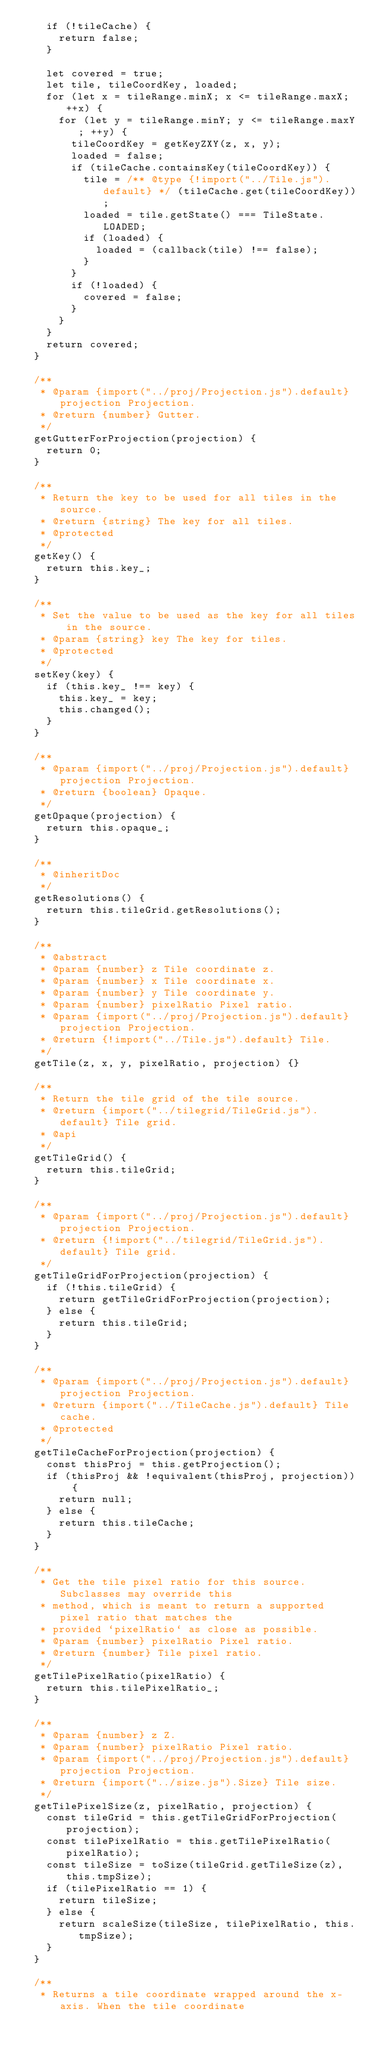Convert code to text. <code><loc_0><loc_0><loc_500><loc_500><_JavaScript_>    if (!tileCache) {
      return false;
    }

    let covered = true;
    let tile, tileCoordKey, loaded;
    for (let x = tileRange.minX; x <= tileRange.maxX; ++x) {
      for (let y = tileRange.minY; y <= tileRange.maxY; ++y) {
        tileCoordKey = getKeyZXY(z, x, y);
        loaded = false;
        if (tileCache.containsKey(tileCoordKey)) {
          tile = /** @type {!import("../Tile.js").default} */ (tileCache.get(tileCoordKey));
          loaded = tile.getState() === TileState.LOADED;
          if (loaded) {
            loaded = (callback(tile) !== false);
          }
        }
        if (!loaded) {
          covered = false;
        }
      }
    }
    return covered;
  }

  /**
   * @param {import("../proj/Projection.js").default} projection Projection.
   * @return {number} Gutter.
   */
  getGutterForProjection(projection) {
    return 0;
  }

  /**
   * Return the key to be used for all tiles in the source.
   * @return {string} The key for all tiles.
   * @protected
   */
  getKey() {
    return this.key_;
  }

  /**
   * Set the value to be used as the key for all tiles in the source.
   * @param {string} key The key for tiles.
   * @protected
   */
  setKey(key) {
    if (this.key_ !== key) {
      this.key_ = key;
      this.changed();
    }
  }

  /**
   * @param {import("../proj/Projection.js").default} projection Projection.
   * @return {boolean} Opaque.
   */
  getOpaque(projection) {
    return this.opaque_;
  }

  /**
   * @inheritDoc
   */
  getResolutions() {
    return this.tileGrid.getResolutions();
  }

  /**
   * @abstract
   * @param {number} z Tile coordinate z.
   * @param {number} x Tile coordinate x.
   * @param {number} y Tile coordinate y.
   * @param {number} pixelRatio Pixel ratio.
   * @param {import("../proj/Projection.js").default} projection Projection.
   * @return {!import("../Tile.js").default} Tile.
   */
  getTile(z, x, y, pixelRatio, projection) {}

  /**
   * Return the tile grid of the tile source.
   * @return {import("../tilegrid/TileGrid.js").default} Tile grid.
   * @api
   */
  getTileGrid() {
    return this.tileGrid;
  }

  /**
   * @param {import("../proj/Projection.js").default} projection Projection.
   * @return {!import("../tilegrid/TileGrid.js").default} Tile grid.
   */
  getTileGridForProjection(projection) {
    if (!this.tileGrid) {
      return getTileGridForProjection(projection);
    } else {
      return this.tileGrid;
    }
  }

  /**
   * @param {import("../proj/Projection.js").default} projection Projection.
   * @return {import("../TileCache.js").default} Tile cache.
   * @protected
   */
  getTileCacheForProjection(projection) {
    const thisProj = this.getProjection();
    if (thisProj && !equivalent(thisProj, projection)) {
      return null;
    } else {
      return this.tileCache;
    }
  }

  /**
   * Get the tile pixel ratio for this source. Subclasses may override this
   * method, which is meant to return a supported pixel ratio that matches the
   * provided `pixelRatio` as close as possible.
   * @param {number} pixelRatio Pixel ratio.
   * @return {number} Tile pixel ratio.
   */
  getTilePixelRatio(pixelRatio) {
    return this.tilePixelRatio_;
  }

  /**
   * @param {number} z Z.
   * @param {number} pixelRatio Pixel ratio.
   * @param {import("../proj/Projection.js").default} projection Projection.
   * @return {import("../size.js").Size} Tile size.
   */
  getTilePixelSize(z, pixelRatio, projection) {
    const tileGrid = this.getTileGridForProjection(projection);
    const tilePixelRatio = this.getTilePixelRatio(pixelRatio);
    const tileSize = toSize(tileGrid.getTileSize(z), this.tmpSize);
    if (tilePixelRatio == 1) {
      return tileSize;
    } else {
      return scaleSize(tileSize, tilePixelRatio, this.tmpSize);
    }
  }

  /**
   * Returns a tile coordinate wrapped around the x-axis. When the tile coordinate</code> 